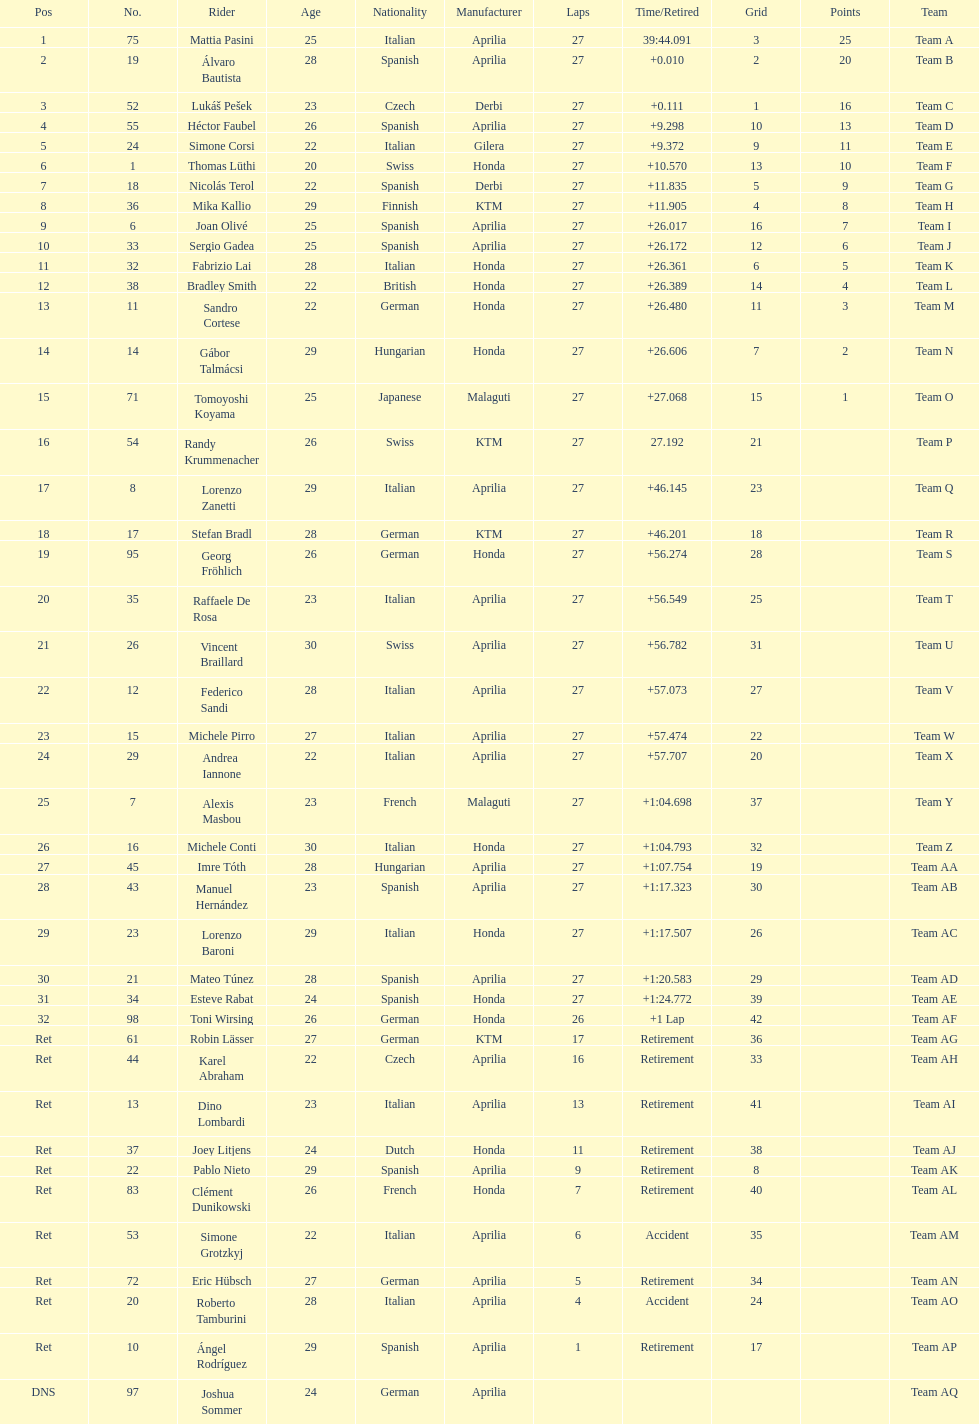Out of all the people who have points, who has the least? Tomoyoshi Koyama. 